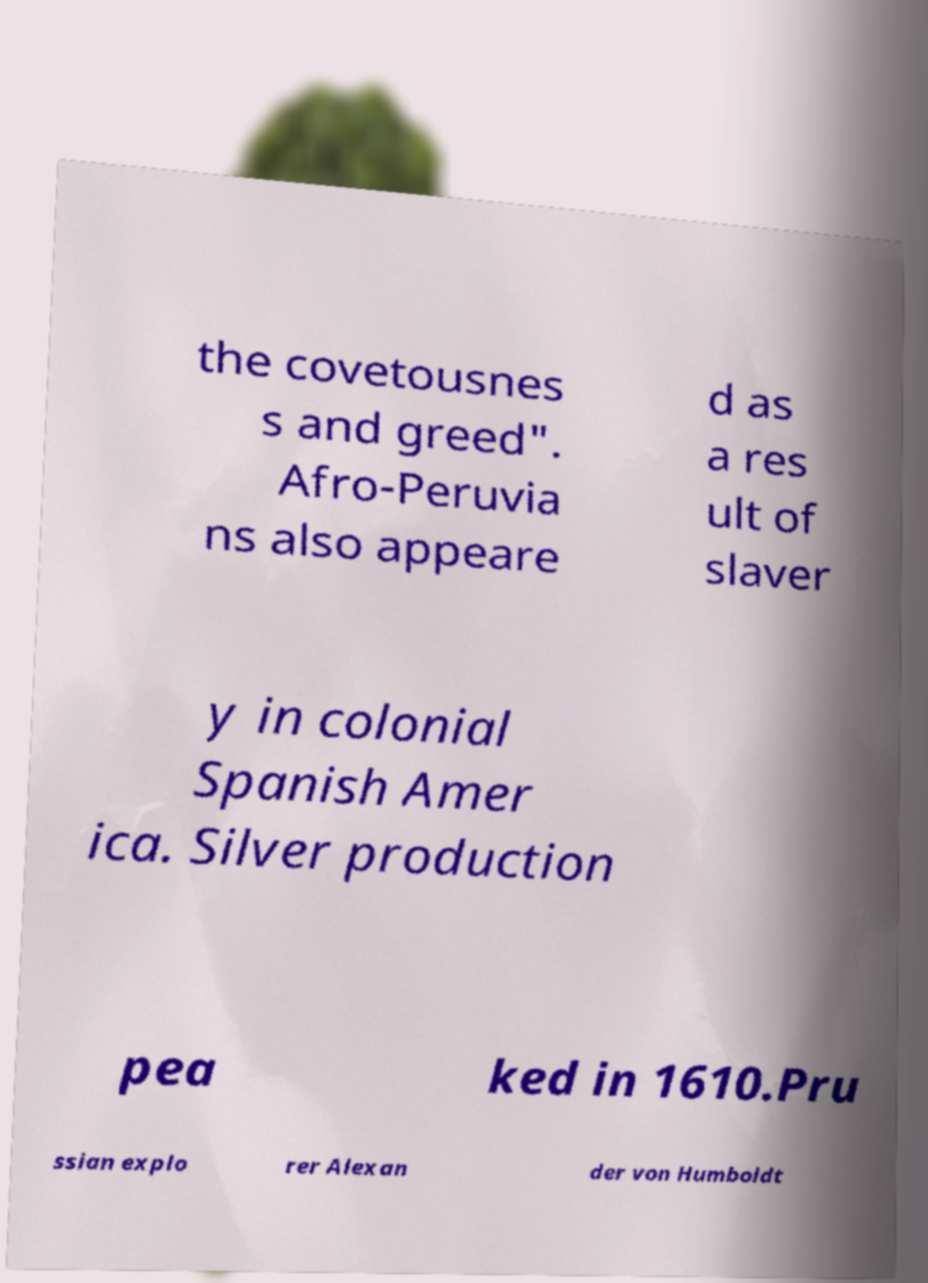Could you assist in decoding the text presented in this image and type it out clearly? the covetousnes s and greed". Afro-Peruvia ns also appeare d as a res ult of slaver y in colonial Spanish Amer ica. Silver production pea ked in 1610.Pru ssian explo rer Alexan der von Humboldt 